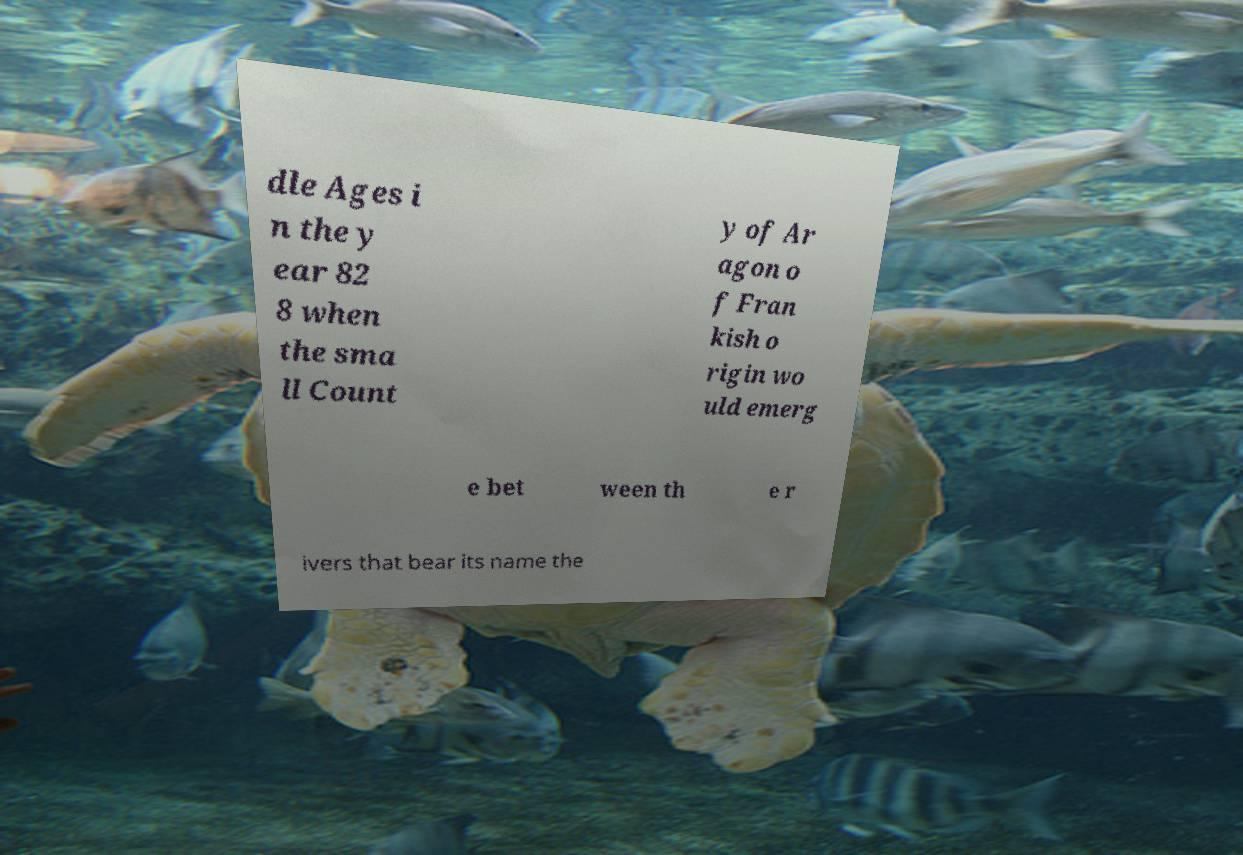Could you extract and type out the text from this image? dle Ages i n the y ear 82 8 when the sma ll Count y of Ar agon o f Fran kish o rigin wo uld emerg e bet ween th e r ivers that bear its name the 